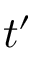Convert formula to latex. <formula><loc_0><loc_0><loc_500><loc_500>t ^ { \prime }</formula> 